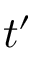Convert formula to latex. <formula><loc_0><loc_0><loc_500><loc_500>t ^ { \prime }</formula> 